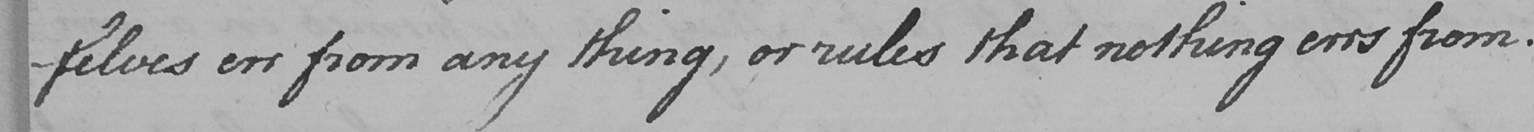Transcribe the text shown in this historical manuscript line. -selves err from any thing , or rules that nothing errs from . 